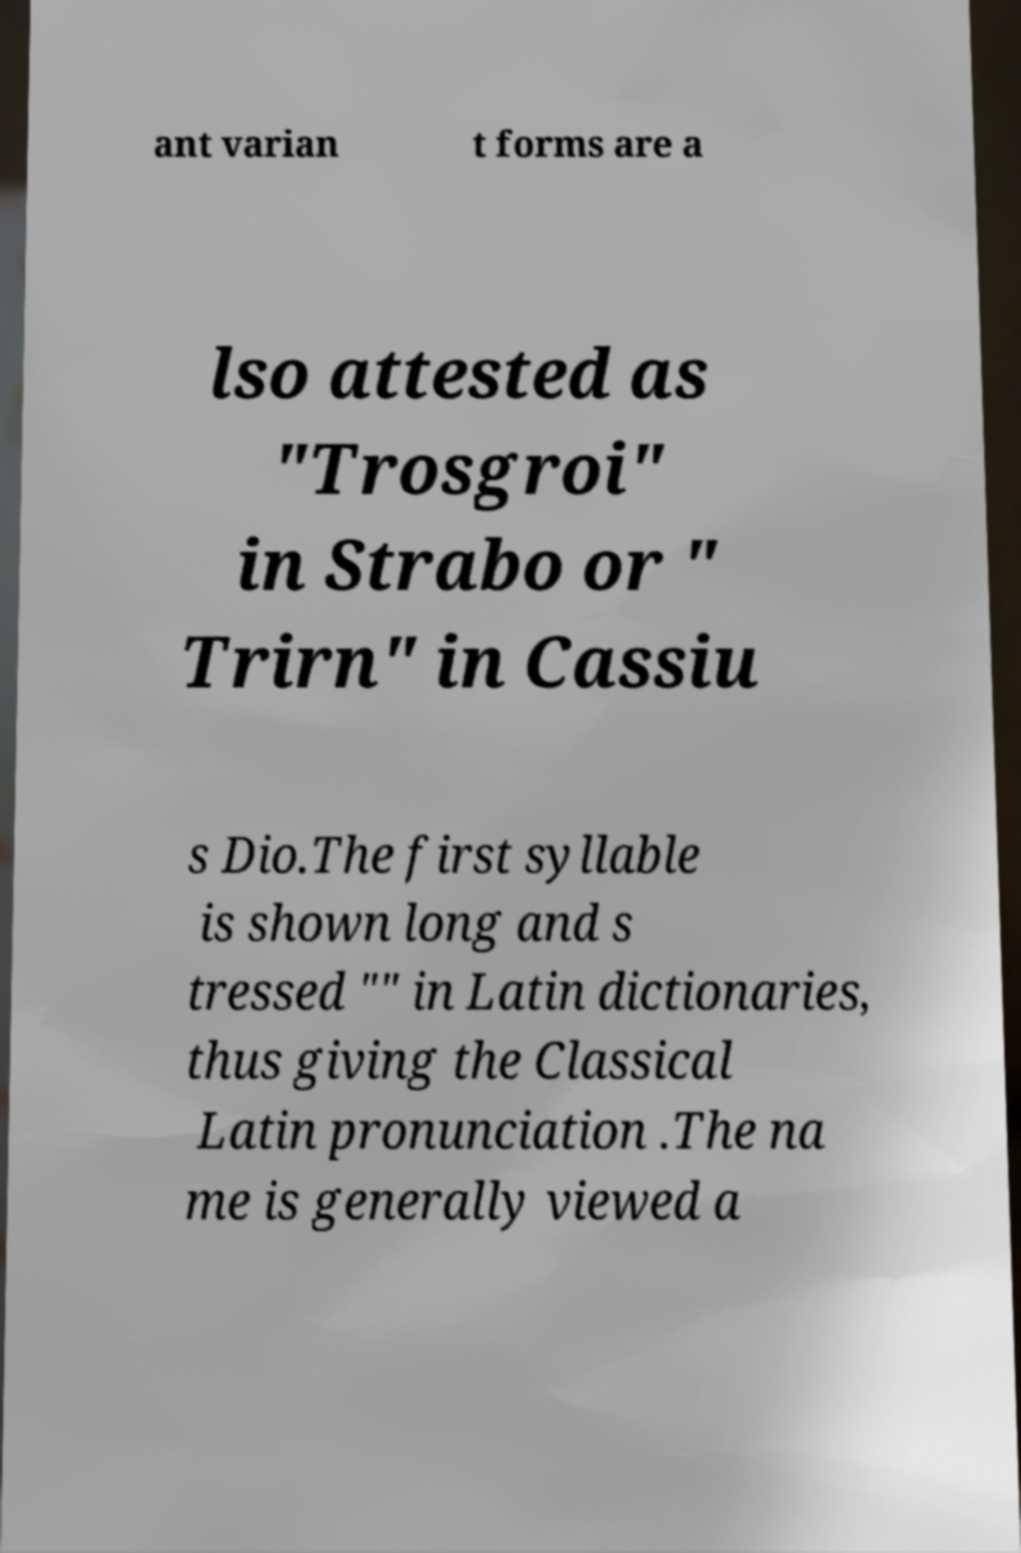Can you accurately transcribe the text from the provided image for me? ant varian t forms are a lso attested as "Trosgroi" in Strabo or " Trirn" in Cassiu s Dio.The first syllable is shown long and s tressed "" in Latin dictionaries, thus giving the Classical Latin pronunciation .The na me is generally viewed a 